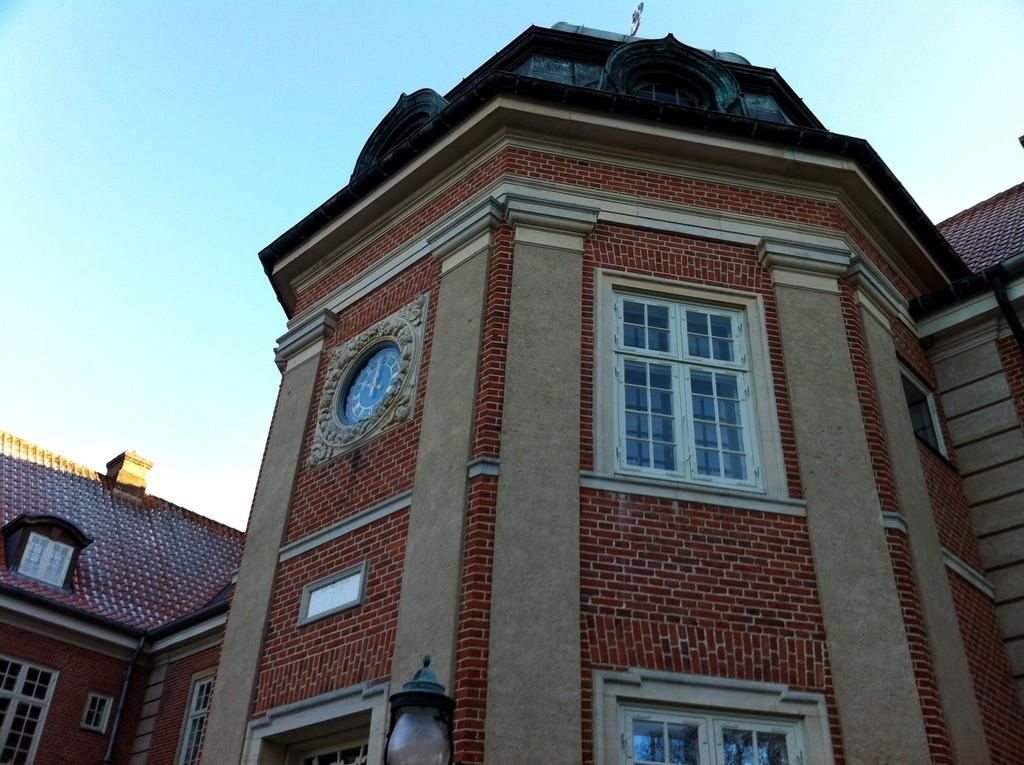What type of structures can be seen in the image? There are buildings in the image. What can be seen illuminating the area in the image? There is a light in the image. What part of the natural environment is visible in the image? The sky is visible in the background of the image. How many eyes can be seen on the buildings in the image? There are no eyes visible on the buildings in the image. 